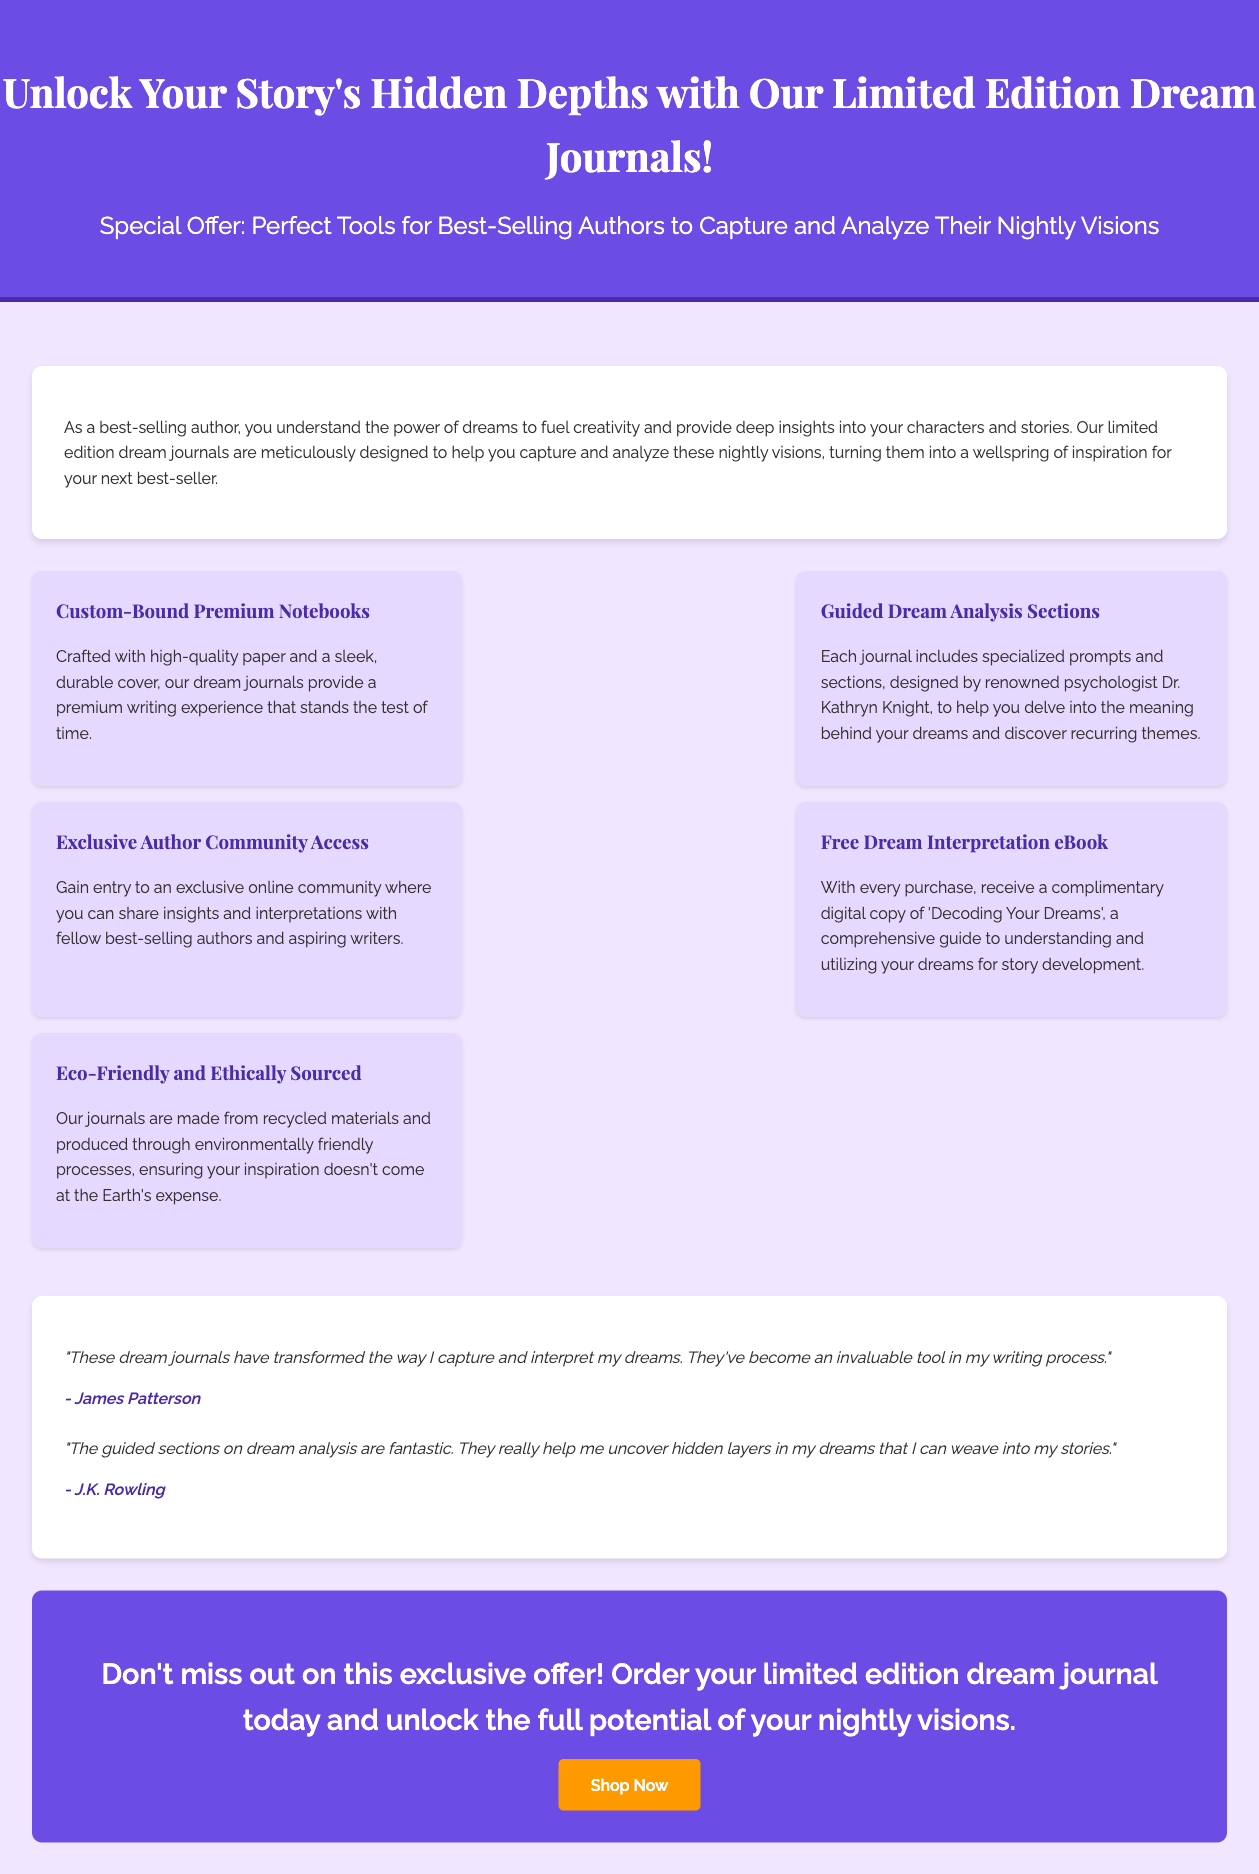What are the journals designed for? The journals are designed to help authors capture and analyze their nightly visions.
Answer: Capturing and analyzing nightly visions Who designed the guided dream analysis sections? The guided dream analysis sections are designed by renowned psychologist Dr. Kathryn Knight.
Answer: Dr. Kathryn Knight What is included with every purchase? Every purchase includes a complimentary digital copy of 'Decoding Your Dreams'.
Answer: 'Decoding Your Dreams' What type of community access do buyers gain? Buyers gain access to an exclusive online community for insights and interpretations.
Answer: Exclusive online community What can the dream journals help authors uncover? The dream journals can help authors uncover recurring themes in their dreams.
Answer: Recurring themes How are the journals produced in terms of environmental impact? The journals are made from recycled materials and produced through environmentally friendly processes.
Answer: Environmentally friendly processes What color is the header background? The header background is a shade of purple (#6b4de6).
Answer: Purple Who is quoted as saying the journals transformed their writing process? James Patterson is quoted as saying the journals transformed his writing process.
Answer: James Patterson What is the call-to-action for purchasing the journals? The call-to-action is to order your limited edition dream journal today.
Answer: Order your limited edition dream journal today 